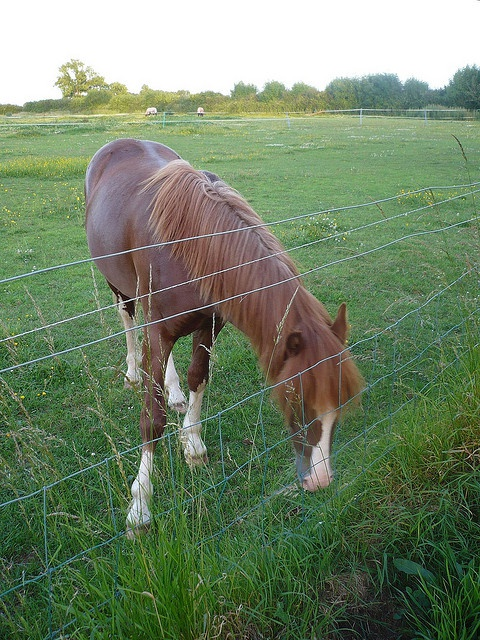Describe the objects in this image and their specific colors. I can see a horse in white, gray, darkgray, and maroon tones in this image. 